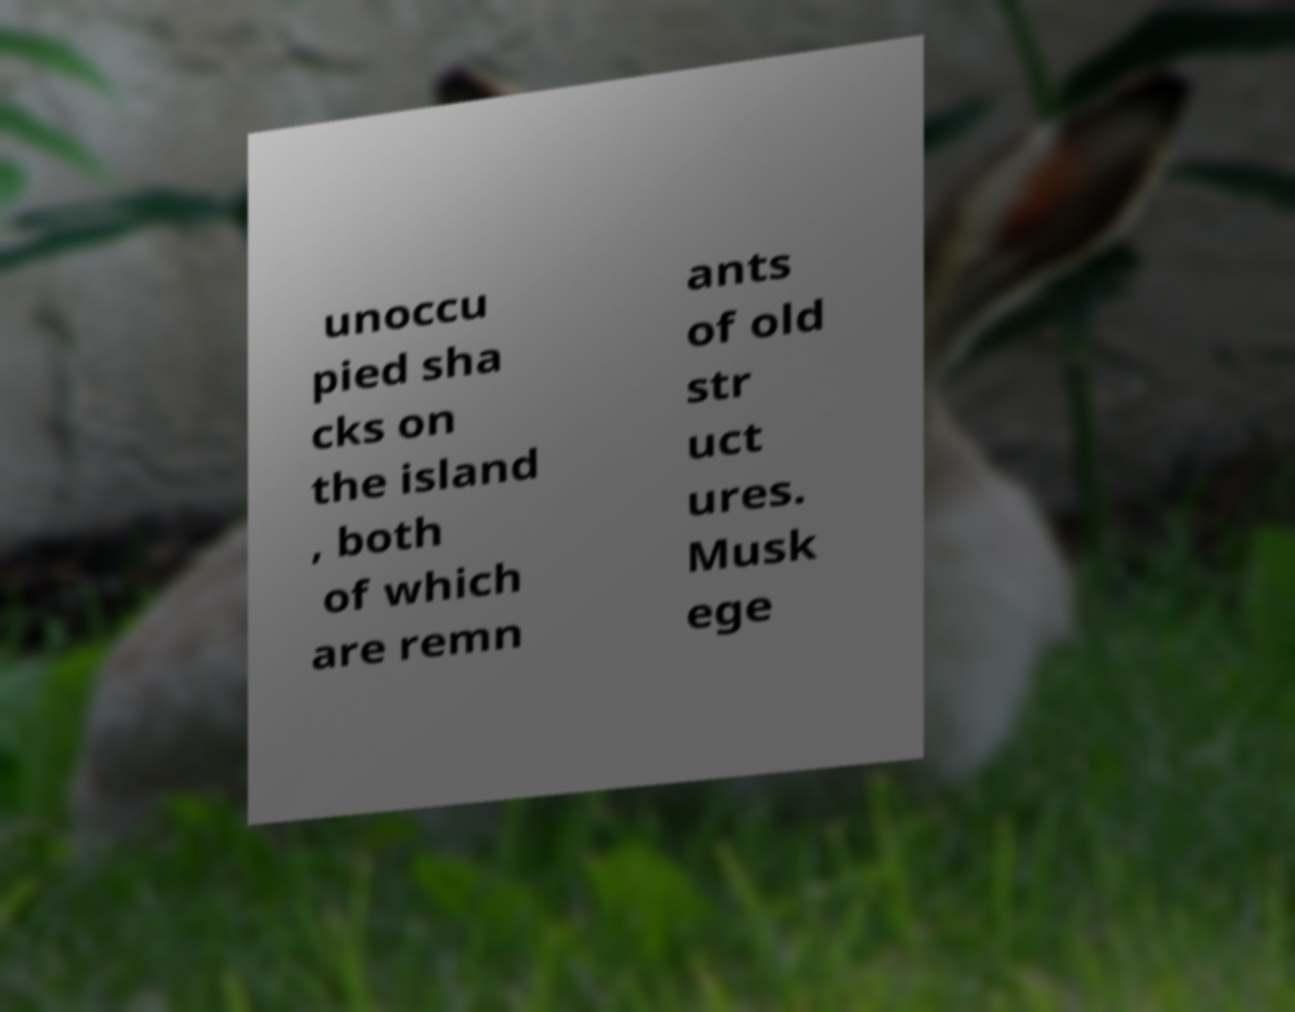Can you read and provide the text displayed in the image?This photo seems to have some interesting text. Can you extract and type it out for me? unoccu pied sha cks on the island , both of which are remn ants of old str uct ures. Musk ege 